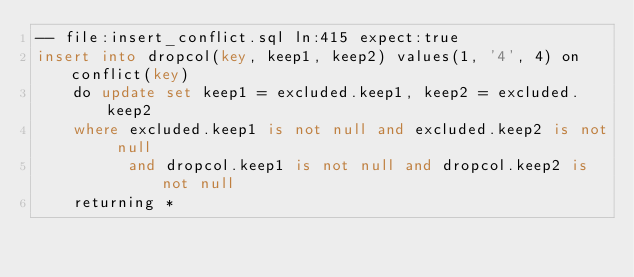<code> <loc_0><loc_0><loc_500><loc_500><_SQL_>-- file:insert_conflict.sql ln:415 expect:true
insert into dropcol(key, keep1, keep2) values(1, '4', 4) on conflict(key)
    do update set keep1 = excluded.keep1, keep2 = excluded.keep2
    where excluded.keep1 is not null and excluded.keep2 is not null
          and dropcol.keep1 is not null and dropcol.keep2 is not null
    returning *
</code> 